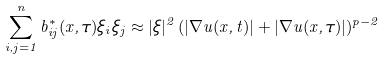Convert formula to latex. <formula><loc_0><loc_0><loc_500><loc_500>\sum _ { i , j = 1 } ^ { n } b ^ { * } _ { i j } ( x , \tau ) \xi _ { i } \xi _ { j } \approx | \xi | ^ { 2 } \, ( | \nabla u ( x , t ) | + | \nabla u ( x , \tau ) | ) ^ { p - 2 }</formula> 